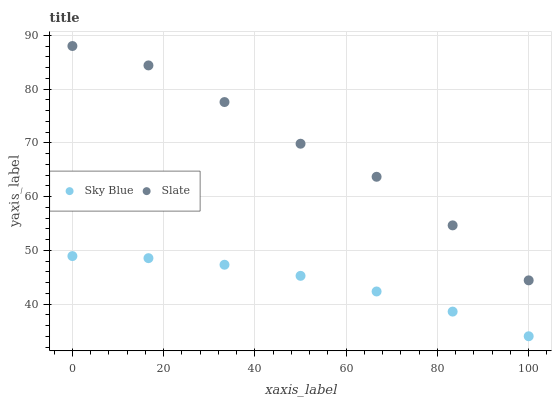Does Sky Blue have the minimum area under the curve?
Answer yes or no. Yes. Does Slate have the maximum area under the curve?
Answer yes or no. Yes. Does Slate have the minimum area under the curve?
Answer yes or no. No. Is Sky Blue the smoothest?
Answer yes or no. Yes. Is Slate the roughest?
Answer yes or no. Yes. Is Slate the smoothest?
Answer yes or no. No. Does Sky Blue have the lowest value?
Answer yes or no. Yes. Does Slate have the lowest value?
Answer yes or no. No. Does Slate have the highest value?
Answer yes or no. Yes. Is Sky Blue less than Slate?
Answer yes or no. Yes. Is Slate greater than Sky Blue?
Answer yes or no. Yes. Does Sky Blue intersect Slate?
Answer yes or no. No. 